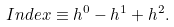<formula> <loc_0><loc_0><loc_500><loc_500>I n d e x \equiv h ^ { 0 } - h ^ { 1 } + h ^ { 2 } .</formula> 